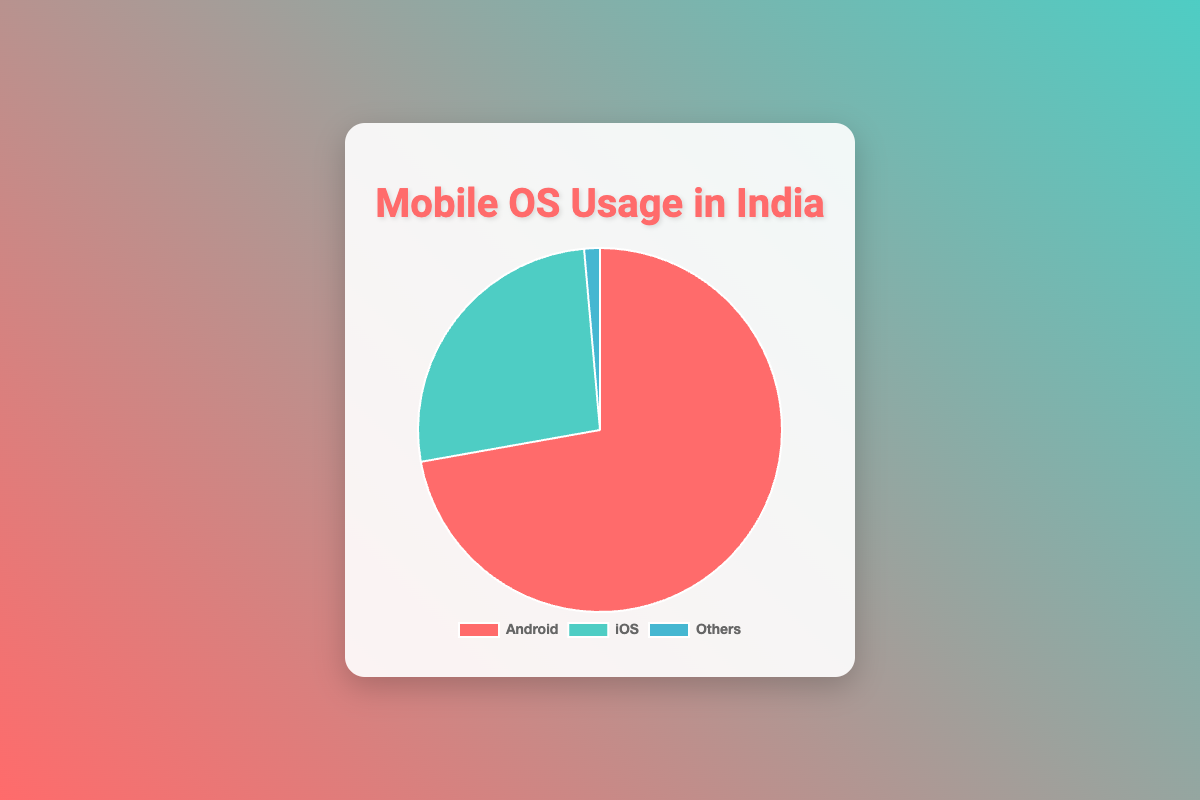What percentage of mobile OS usage does Android represent in India? The pie chart shows that Android usage in India is represented by a section marked with a specific color. This section is labeled with the percentage value directly.
Answer: 72.2% How does iOS usage in India compare to Others? To compare iOS usage to Others, look at the percentage values represented by their respective sections. The iOS section shows 26.4%, while the Others section shows 1.4%.
Answer: iOS usage is 25% higher What is the combined percentage of Android and iOS usage in India? Add the percentage values for Android and iOS. According to the pie chart, Android is 72.2% and iOS is 26.4%. So, the sum is 72.2 + 26.4.
Answer: 98.6% Which section of the pie chart is the smallest in terms of mobile OS usage? The pie chart segments are colored and labeled with their usage percentages. The section with the lowest percentage is the smallest.
Answer: Others What is the percentage difference between Android and iOS usage in India? Subtract the iOS percentage from the Android percentage. According to the chart, Android is 72.2% and iOS is 26.4%. So, compute 72.2 - 26.4.
Answer: 45.8% Is the combined usage of iOS and Others greater than Android usage? First, sum the percentages of iOS and Others (26.4 + 1.4). Then compare this sum to the Android percentage (72.2).
Answer: No, 27.8% < 72.2% Which color in the pie chart represents Android usage? The chart distinguishes each mobile OS with a different color for easy identification. Look for the color associated with the Android section.
Answer: Red 